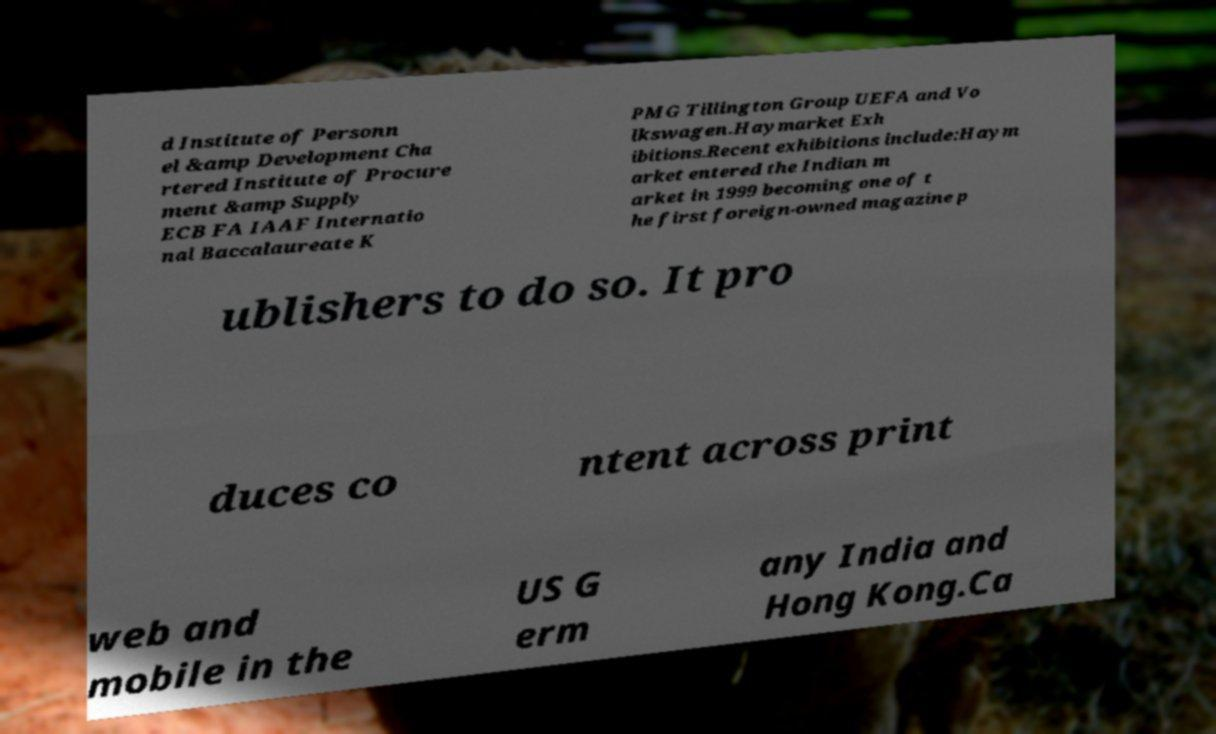Could you extract and type out the text from this image? d Institute of Personn el &amp Development Cha rtered Institute of Procure ment &amp Supply ECB FA IAAF Internatio nal Baccalaureate K PMG Tillington Group UEFA and Vo lkswagen.Haymarket Exh ibitions.Recent exhibitions include:Haym arket entered the Indian m arket in 1999 becoming one of t he first foreign-owned magazine p ublishers to do so. It pro duces co ntent across print web and mobile in the US G erm any India and Hong Kong.Ca 